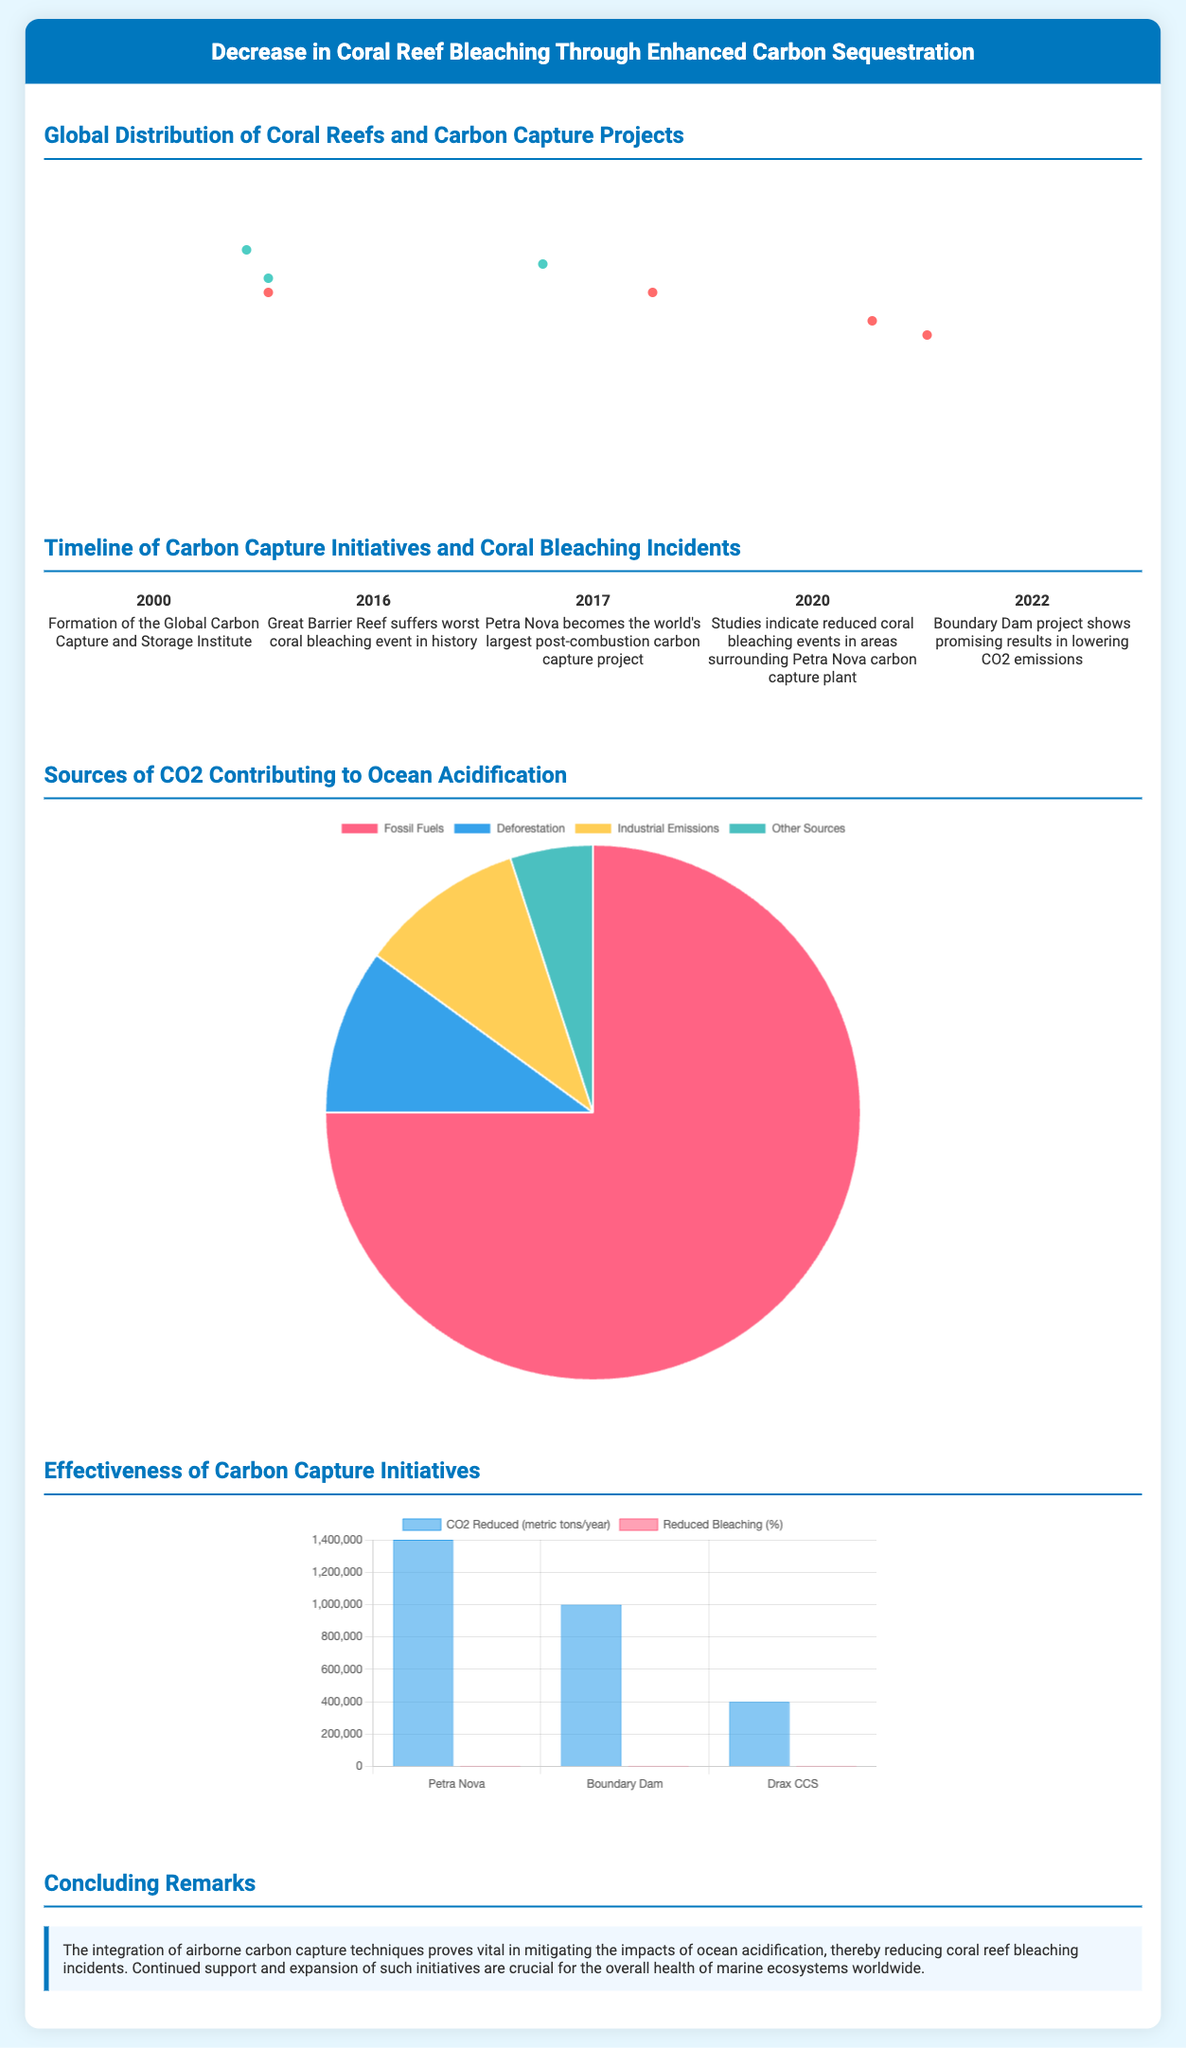What are the two types of significant projects depicted on the world map? The world map shows coral reef locations and carbon capture projects.
Answer: Coral reefs and carbon capture projects What year was the Global Carbon Capture and Storage Institute formed? The timeline explicitly states this event took place in the year 2000.
Answer: 2000 How much CO2 does the Petra Nova project reduce per year? The bar chart indicates the Petra Nova project reduces 1,400,000 metric tons of CO2 annually.
Answer: 1,400,000 What percentage reduction in coral bleaching is associated with the Boundary Dam project? According to the bar chart, the Boundary Dam project shows a 15% reduction in coral bleaching incidents.
Answer: 15% Which coral reef suffered the worst bleaching event in history? The timeline details that the Great Barrier Reef experienced this event in 2016.
Answer: Great Barrier Reef What is the main conclusion about airborne carbon capture techniques presented in the document? The concluding remarks highlight that these techniques are vital for mitigating ocean acidification impacts.
Answer: Vital for mitigating ocean acidification What color represents fossil fuel contributions in the pie chart? The pie chart uses a specific color to represent fossil fuels, which is indicated in the key.
Answer: Pink What significant development occurred in 2017 related to carbon capture? The timeline notes that Petra Nova became the world's largest post-combustion carbon capture project in this year.
Answer: Largest post-combustion carbon capture project How many sources of CO2 are identified in the pie chart? The pie chart enumerates specific sources contributing to ocean acidification.
Answer: Four sources 